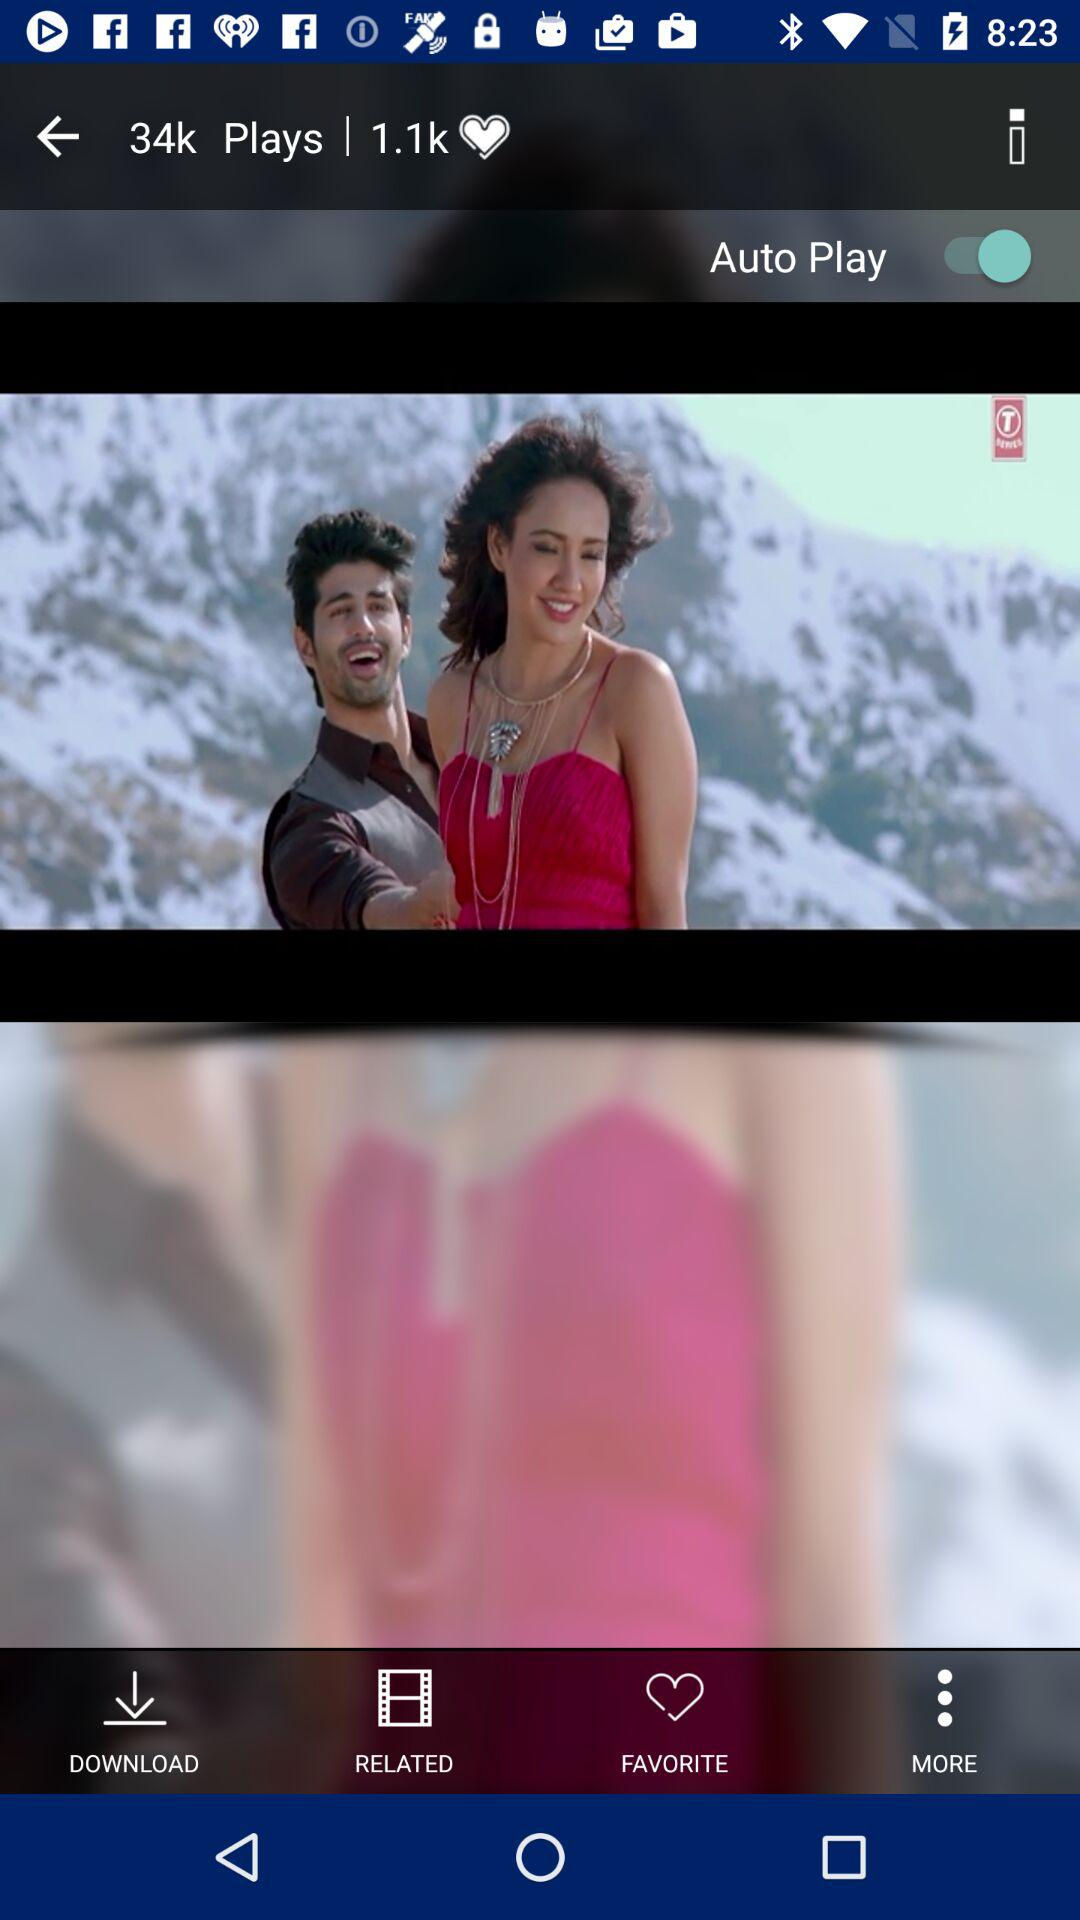How many times has this video been played? This video has been played 34k times. 